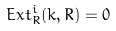Convert formula to latex. <formula><loc_0><loc_0><loc_500><loc_500>E x t _ { R } ^ { i } ( k , R ) = 0</formula> 